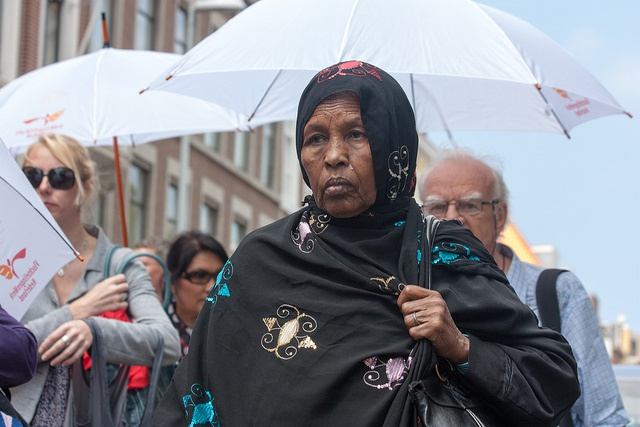Describe the objects in this image and their specific colors. I can see people in gray and black tones, umbrella in gray, lavender, and darkgray tones, people in gray, darkgray, and tan tones, umbrella in gray, white, darkgray, and brown tones, and people in gray and darkgray tones in this image. 